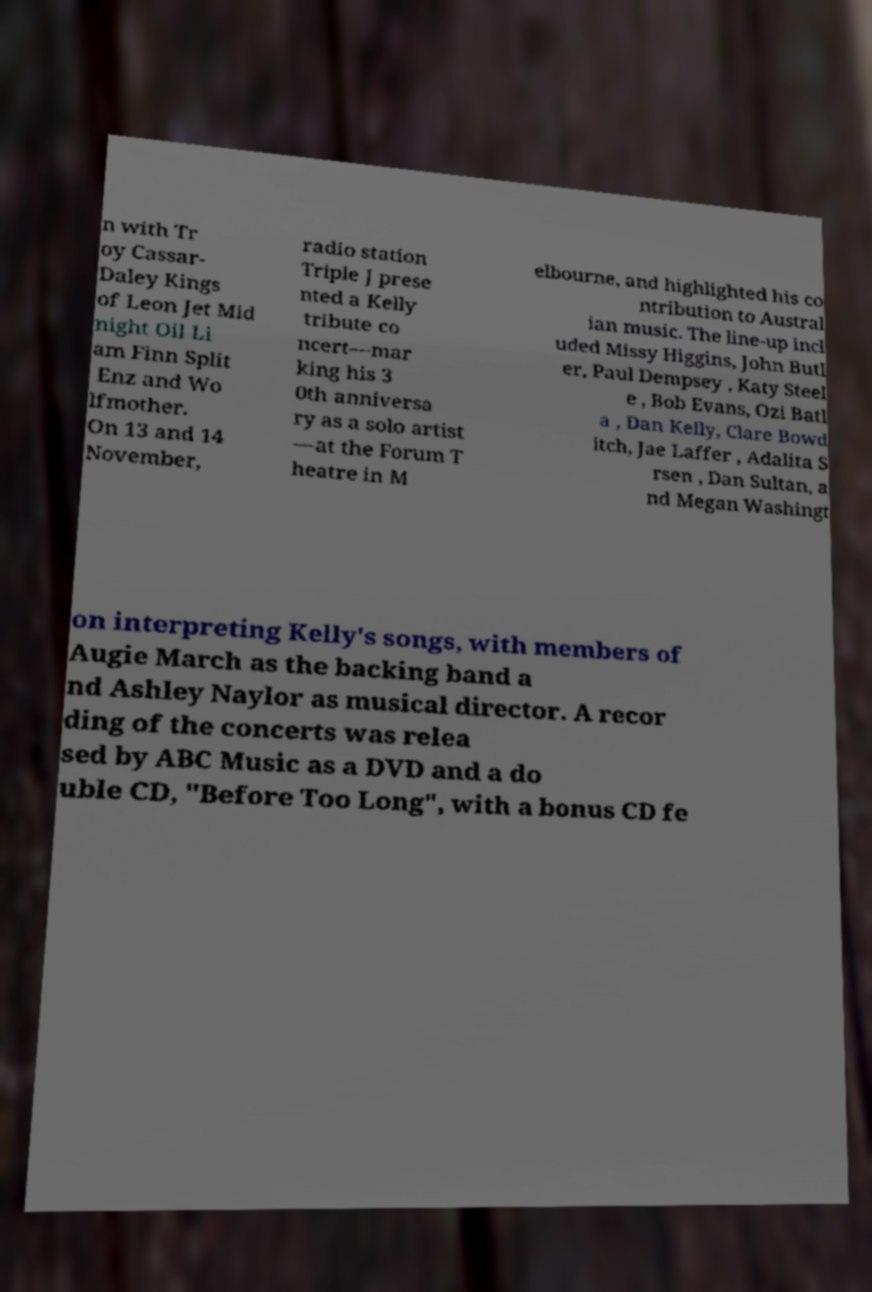Can you read and provide the text displayed in the image?This photo seems to have some interesting text. Can you extract and type it out for me? n with Tr oy Cassar- Daley Kings of Leon Jet Mid night Oil Li am Finn Split Enz and Wo lfmother. On 13 and 14 November, radio station Triple J prese nted a Kelly tribute co ncert—mar king his 3 0th anniversa ry as a solo artist —at the Forum T heatre in M elbourne, and highlighted his co ntribution to Austral ian music. The line-up incl uded Missy Higgins, John Butl er, Paul Dempsey , Katy Steel e , Bob Evans, Ozi Batl a , Dan Kelly, Clare Bowd itch, Jae Laffer , Adalita S rsen , Dan Sultan, a nd Megan Washingt on interpreting Kelly's songs, with members of Augie March as the backing band a nd Ashley Naylor as musical director. A recor ding of the concerts was relea sed by ABC Music as a DVD and a do uble CD, "Before Too Long", with a bonus CD fe 